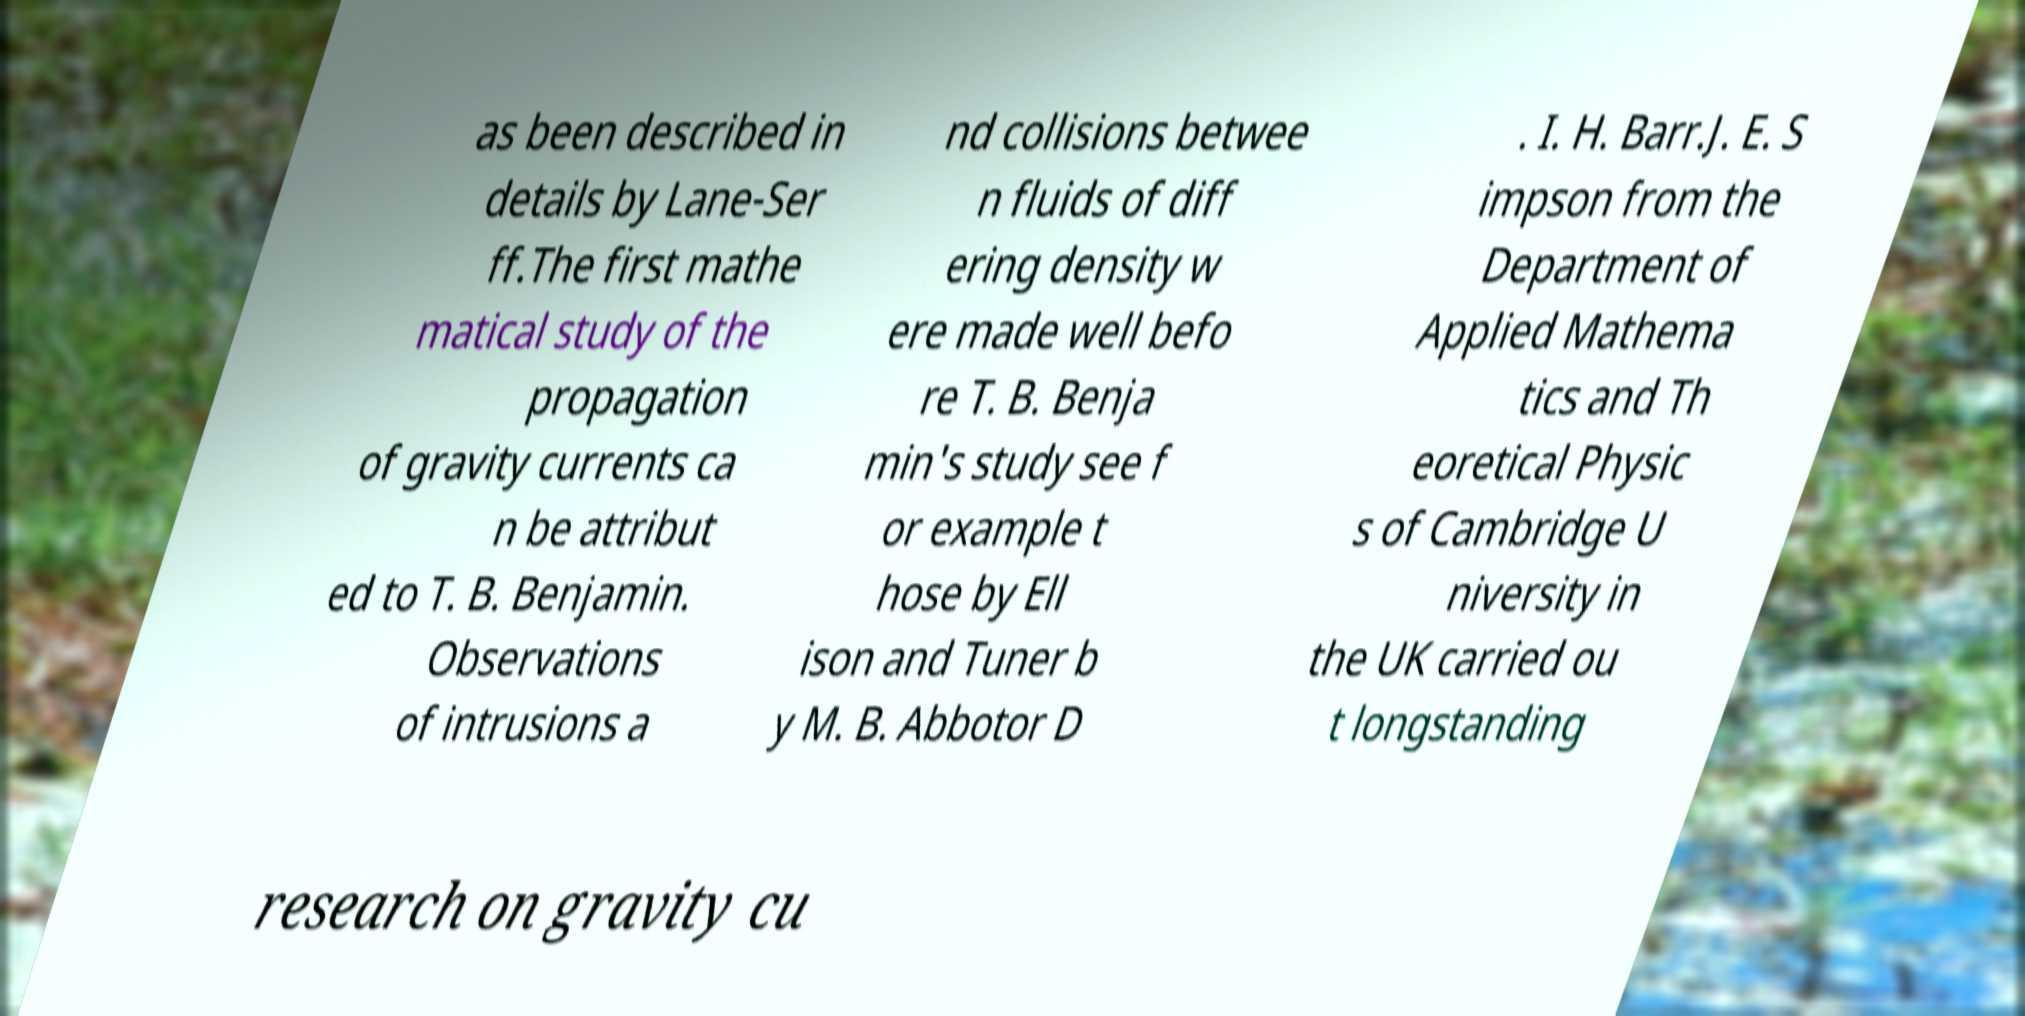Please identify and transcribe the text found in this image. as been described in details by Lane-Ser ff.The first mathe matical study of the propagation of gravity currents ca n be attribut ed to T. B. Benjamin. Observations of intrusions a nd collisions betwee n fluids of diff ering density w ere made well befo re T. B. Benja min's study see f or example t hose by Ell ison and Tuner b y M. B. Abbotor D . I. H. Barr.J. E. S impson from the Department of Applied Mathema tics and Th eoretical Physic s of Cambridge U niversity in the UK carried ou t longstanding research on gravity cu 